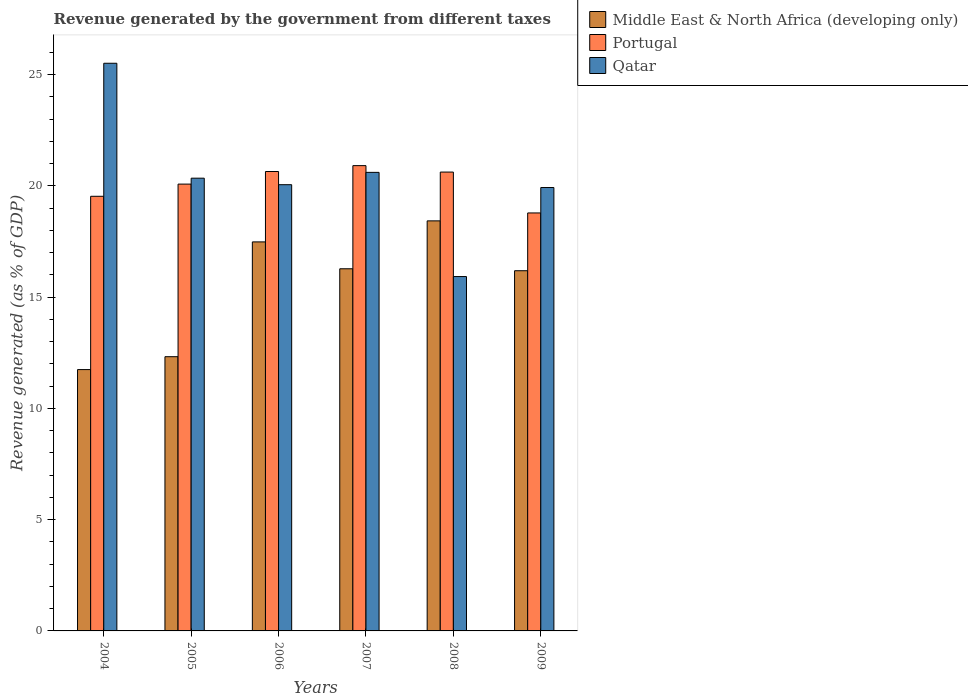How many different coloured bars are there?
Your response must be concise. 3. How many groups of bars are there?
Ensure brevity in your answer.  6. Are the number of bars per tick equal to the number of legend labels?
Give a very brief answer. Yes. Are the number of bars on each tick of the X-axis equal?
Provide a succinct answer. Yes. What is the revenue generated by the government in Qatar in 2008?
Ensure brevity in your answer.  15.92. Across all years, what is the maximum revenue generated by the government in Qatar?
Give a very brief answer. 25.51. Across all years, what is the minimum revenue generated by the government in Portugal?
Ensure brevity in your answer.  18.78. In which year was the revenue generated by the government in Middle East & North Africa (developing only) maximum?
Give a very brief answer. 2008. In which year was the revenue generated by the government in Qatar minimum?
Your response must be concise. 2008. What is the total revenue generated by the government in Qatar in the graph?
Your answer should be compact. 122.36. What is the difference between the revenue generated by the government in Portugal in 2008 and that in 2009?
Your answer should be very brief. 1.84. What is the difference between the revenue generated by the government in Portugal in 2008 and the revenue generated by the government in Middle East & North Africa (developing only) in 2004?
Offer a very short reply. 8.88. What is the average revenue generated by the government in Portugal per year?
Your answer should be very brief. 20.09. In the year 2006, what is the difference between the revenue generated by the government in Portugal and revenue generated by the government in Middle East & North Africa (developing only)?
Your response must be concise. 3.16. What is the ratio of the revenue generated by the government in Portugal in 2006 to that in 2009?
Make the answer very short. 1.1. Is the difference between the revenue generated by the government in Portugal in 2005 and 2008 greater than the difference between the revenue generated by the government in Middle East & North Africa (developing only) in 2005 and 2008?
Offer a terse response. Yes. What is the difference between the highest and the second highest revenue generated by the government in Portugal?
Keep it short and to the point. 0.26. What is the difference between the highest and the lowest revenue generated by the government in Qatar?
Your answer should be compact. 9.58. In how many years, is the revenue generated by the government in Qatar greater than the average revenue generated by the government in Qatar taken over all years?
Provide a short and direct response. 2. Is the sum of the revenue generated by the government in Qatar in 2005 and 2007 greater than the maximum revenue generated by the government in Portugal across all years?
Your answer should be very brief. Yes. What does the 1st bar from the right in 2009 represents?
Give a very brief answer. Qatar. How many bars are there?
Ensure brevity in your answer.  18. How many years are there in the graph?
Ensure brevity in your answer.  6. What is the difference between two consecutive major ticks on the Y-axis?
Provide a short and direct response. 5. Are the values on the major ticks of Y-axis written in scientific E-notation?
Provide a short and direct response. No. Does the graph contain any zero values?
Ensure brevity in your answer.  No. Where does the legend appear in the graph?
Provide a short and direct response. Top right. How are the legend labels stacked?
Give a very brief answer. Vertical. What is the title of the graph?
Your answer should be compact. Revenue generated by the government from different taxes. What is the label or title of the Y-axis?
Your answer should be compact. Revenue generated (as % of GDP). What is the Revenue generated (as % of GDP) in Middle East & North Africa (developing only) in 2004?
Your response must be concise. 11.74. What is the Revenue generated (as % of GDP) in Portugal in 2004?
Make the answer very short. 19.53. What is the Revenue generated (as % of GDP) of Qatar in 2004?
Your answer should be compact. 25.51. What is the Revenue generated (as % of GDP) of Middle East & North Africa (developing only) in 2005?
Give a very brief answer. 12.32. What is the Revenue generated (as % of GDP) in Portugal in 2005?
Offer a very short reply. 20.08. What is the Revenue generated (as % of GDP) of Qatar in 2005?
Your response must be concise. 20.34. What is the Revenue generated (as % of GDP) of Middle East & North Africa (developing only) in 2006?
Ensure brevity in your answer.  17.48. What is the Revenue generated (as % of GDP) in Portugal in 2006?
Give a very brief answer. 20.64. What is the Revenue generated (as % of GDP) in Qatar in 2006?
Ensure brevity in your answer.  20.05. What is the Revenue generated (as % of GDP) in Middle East & North Africa (developing only) in 2007?
Provide a short and direct response. 16.27. What is the Revenue generated (as % of GDP) in Portugal in 2007?
Make the answer very short. 20.91. What is the Revenue generated (as % of GDP) of Qatar in 2007?
Provide a short and direct response. 20.61. What is the Revenue generated (as % of GDP) of Middle East & North Africa (developing only) in 2008?
Your answer should be very brief. 18.43. What is the Revenue generated (as % of GDP) in Portugal in 2008?
Your answer should be very brief. 20.62. What is the Revenue generated (as % of GDP) of Qatar in 2008?
Make the answer very short. 15.92. What is the Revenue generated (as % of GDP) in Middle East & North Africa (developing only) in 2009?
Offer a terse response. 16.19. What is the Revenue generated (as % of GDP) of Portugal in 2009?
Offer a terse response. 18.78. What is the Revenue generated (as % of GDP) in Qatar in 2009?
Offer a very short reply. 19.92. Across all years, what is the maximum Revenue generated (as % of GDP) of Middle East & North Africa (developing only)?
Offer a very short reply. 18.43. Across all years, what is the maximum Revenue generated (as % of GDP) of Portugal?
Provide a short and direct response. 20.91. Across all years, what is the maximum Revenue generated (as % of GDP) in Qatar?
Your response must be concise. 25.51. Across all years, what is the minimum Revenue generated (as % of GDP) in Middle East & North Africa (developing only)?
Make the answer very short. 11.74. Across all years, what is the minimum Revenue generated (as % of GDP) in Portugal?
Offer a terse response. 18.78. Across all years, what is the minimum Revenue generated (as % of GDP) in Qatar?
Give a very brief answer. 15.92. What is the total Revenue generated (as % of GDP) of Middle East & North Africa (developing only) in the graph?
Keep it short and to the point. 92.43. What is the total Revenue generated (as % of GDP) in Portugal in the graph?
Keep it short and to the point. 120.56. What is the total Revenue generated (as % of GDP) in Qatar in the graph?
Your answer should be compact. 122.36. What is the difference between the Revenue generated (as % of GDP) in Middle East & North Africa (developing only) in 2004 and that in 2005?
Make the answer very short. -0.58. What is the difference between the Revenue generated (as % of GDP) of Portugal in 2004 and that in 2005?
Offer a very short reply. -0.55. What is the difference between the Revenue generated (as % of GDP) in Qatar in 2004 and that in 2005?
Give a very brief answer. 5.16. What is the difference between the Revenue generated (as % of GDP) in Middle East & North Africa (developing only) in 2004 and that in 2006?
Offer a very short reply. -5.74. What is the difference between the Revenue generated (as % of GDP) of Portugal in 2004 and that in 2006?
Ensure brevity in your answer.  -1.11. What is the difference between the Revenue generated (as % of GDP) in Qatar in 2004 and that in 2006?
Give a very brief answer. 5.46. What is the difference between the Revenue generated (as % of GDP) of Middle East & North Africa (developing only) in 2004 and that in 2007?
Your answer should be very brief. -4.53. What is the difference between the Revenue generated (as % of GDP) in Portugal in 2004 and that in 2007?
Give a very brief answer. -1.38. What is the difference between the Revenue generated (as % of GDP) of Qatar in 2004 and that in 2007?
Offer a terse response. 4.9. What is the difference between the Revenue generated (as % of GDP) of Middle East & North Africa (developing only) in 2004 and that in 2008?
Provide a short and direct response. -6.68. What is the difference between the Revenue generated (as % of GDP) of Portugal in 2004 and that in 2008?
Your answer should be very brief. -1.09. What is the difference between the Revenue generated (as % of GDP) of Qatar in 2004 and that in 2008?
Provide a succinct answer. 9.58. What is the difference between the Revenue generated (as % of GDP) of Middle East & North Africa (developing only) in 2004 and that in 2009?
Ensure brevity in your answer.  -4.44. What is the difference between the Revenue generated (as % of GDP) in Portugal in 2004 and that in 2009?
Provide a succinct answer. 0.75. What is the difference between the Revenue generated (as % of GDP) of Qatar in 2004 and that in 2009?
Give a very brief answer. 5.58. What is the difference between the Revenue generated (as % of GDP) in Middle East & North Africa (developing only) in 2005 and that in 2006?
Provide a short and direct response. -5.16. What is the difference between the Revenue generated (as % of GDP) in Portugal in 2005 and that in 2006?
Make the answer very short. -0.57. What is the difference between the Revenue generated (as % of GDP) in Qatar in 2005 and that in 2006?
Provide a short and direct response. 0.29. What is the difference between the Revenue generated (as % of GDP) in Middle East & North Africa (developing only) in 2005 and that in 2007?
Your response must be concise. -3.95. What is the difference between the Revenue generated (as % of GDP) of Portugal in 2005 and that in 2007?
Your answer should be compact. -0.83. What is the difference between the Revenue generated (as % of GDP) of Qatar in 2005 and that in 2007?
Your response must be concise. -0.26. What is the difference between the Revenue generated (as % of GDP) of Middle East & North Africa (developing only) in 2005 and that in 2008?
Keep it short and to the point. -6.1. What is the difference between the Revenue generated (as % of GDP) of Portugal in 2005 and that in 2008?
Offer a terse response. -0.54. What is the difference between the Revenue generated (as % of GDP) in Qatar in 2005 and that in 2008?
Provide a short and direct response. 4.42. What is the difference between the Revenue generated (as % of GDP) of Middle East & North Africa (developing only) in 2005 and that in 2009?
Give a very brief answer. -3.86. What is the difference between the Revenue generated (as % of GDP) of Portugal in 2005 and that in 2009?
Keep it short and to the point. 1.3. What is the difference between the Revenue generated (as % of GDP) in Qatar in 2005 and that in 2009?
Your response must be concise. 0.42. What is the difference between the Revenue generated (as % of GDP) in Middle East & North Africa (developing only) in 2006 and that in 2007?
Keep it short and to the point. 1.21. What is the difference between the Revenue generated (as % of GDP) in Portugal in 2006 and that in 2007?
Give a very brief answer. -0.26. What is the difference between the Revenue generated (as % of GDP) in Qatar in 2006 and that in 2007?
Provide a short and direct response. -0.55. What is the difference between the Revenue generated (as % of GDP) of Middle East & North Africa (developing only) in 2006 and that in 2008?
Keep it short and to the point. -0.95. What is the difference between the Revenue generated (as % of GDP) of Portugal in 2006 and that in 2008?
Your answer should be compact. 0.03. What is the difference between the Revenue generated (as % of GDP) in Qatar in 2006 and that in 2008?
Provide a succinct answer. 4.13. What is the difference between the Revenue generated (as % of GDP) in Middle East & North Africa (developing only) in 2006 and that in 2009?
Make the answer very short. 1.3. What is the difference between the Revenue generated (as % of GDP) in Portugal in 2006 and that in 2009?
Provide a short and direct response. 1.86. What is the difference between the Revenue generated (as % of GDP) in Qatar in 2006 and that in 2009?
Ensure brevity in your answer.  0.13. What is the difference between the Revenue generated (as % of GDP) of Middle East & North Africa (developing only) in 2007 and that in 2008?
Provide a succinct answer. -2.15. What is the difference between the Revenue generated (as % of GDP) in Portugal in 2007 and that in 2008?
Give a very brief answer. 0.29. What is the difference between the Revenue generated (as % of GDP) of Qatar in 2007 and that in 2008?
Provide a succinct answer. 4.68. What is the difference between the Revenue generated (as % of GDP) in Middle East & North Africa (developing only) in 2007 and that in 2009?
Keep it short and to the point. 0.09. What is the difference between the Revenue generated (as % of GDP) of Portugal in 2007 and that in 2009?
Provide a short and direct response. 2.13. What is the difference between the Revenue generated (as % of GDP) of Qatar in 2007 and that in 2009?
Offer a very short reply. 0.68. What is the difference between the Revenue generated (as % of GDP) in Middle East & North Africa (developing only) in 2008 and that in 2009?
Keep it short and to the point. 2.24. What is the difference between the Revenue generated (as % of GDP) in Portugal in 2008 and that in 2009?
Give a very brief answer. 1.84. What is the difference between the Revenue generated (as % of GDP) in Qatar in 2008 and that in 2009?
Provide a succinct answer. -4. What is the difference between the Revenue generated (as % of GDP) in Middle East & North Africa (developing only) in 2004 and the Revenue generated (as % of GDP) in Portugal in 2005?
Make the answer very short. -8.34. What is the difference between the Revenue generated (as % of GDP) of Middle East & North Africa (developing only) in 2004 and the Revenue generated (as % of GDP) of Qatar in 2005?
Make the answer very short. -8.6. What is the difference between the Revenue generated (as % of GDP) in Portugal in 2004 and the Revenue generated (as % of GDP) in Qatar in 2005?
Offer a very short reply. -0.81. What is the difference between the Revenue generated (as % of GDP) of Middle East & North Africa (developing only) in 2004 and the Revenue generated (as % of GDP) of Portugal in 2006?
Keep it short and to the point. -8.9. What is the difference between the Revenue generated (as % of GDP) of Middle East & North Africa (developing only) in 2004 and the Revenue generated (as % of GDP) of Qatar in 2006?
Your response must be concise. -8.31. What is the difference between the Revenue generated (as % of GDP) of Portugal in 2004 and the Revenue generated (as % of GDP) of Qatar in 2006?
Your response must be concise. -0.52. What is the difference between the Revenue generated (as % of GDP) in Middle East & North Africa (developing only) in 2004 and the Revenue generated (as % of GDP) in Portugal in 2007?
Give a very brief answer. -9.16. What is the difference between the Revenue generated (as % of GDP) in Middle East & North Africa (developing only) in 2004 and the Revenue generated (as % of GDP) in Qatar in 2007?
Keep it short and to the point. -8.86. What is the difference between the Revenue generated (as % of GDP) in Portugal in 2004 and the Revenue generated (as % of GDP) in Qatar in 2007?
Give a very brief answer. -1.07. What is the difference between the Revenue generated (as % of GDP) in Middle East & North Africa (developing only) in 2004 and the Revenue generated (as % of GDP) in Portugal in 2008?
Your answer should be very brief. -8.88. What is the difference between the Revenue generated (as % of GDP) in Middle East & North Africa (developing only) in 2004 and the Revenue generated (as % of GDP) in Qatar in 2008?
Keep it short and to the point. -4.18. What is the difference between the Revenue generated (as % of GDP) in Portugal in 2004 and the Revenue generated (as % of GDP) in Qatar in 2008?
Offer a very short reply. 3.61. What is the difference between the Revenue generated (as % of GDP) in Middle East & North Africa (developing only) in 2004 and the Revenue generated (as % of GDP) in Portugal in 2009?
Provide a short and direct response. -7.04. What is the difference between the Revenue generated (as % of GDP) of Middle East & North Africa (developing only) in 2004 and the Revenue generated (as % of GDP) of Qatar in 2009?
Keep it short and to the point. -8.18. What is the difference between the Revenue generated (as % of GDP) in Portugal in 2004 and the Revenue generated (as % of GDP) in Qatar in 2009?
Ensure brevity in your answer.  -0.39. What is the difference between the Revenue generated (as % of GDP) of Middle East & North Africa (developing only) in 2005 and the Revenue generated (as % of GDP) of Portugal in 2006?
Offer a very short reply. -8.32. What is the difference between the Revenue generated (as % of GDP) of Middle East & North Africa (developing only) in 2005 and the Revenue generated (as % of GDP) of Qatar in 2006?
Keep it short and to the point. -7.73. What is the difference between the Revenue generated (as % of GDP) in Portugal in 2005 and the Revenue generated (as % of GDP) in Qatar in 2006?
Ensure brevity in your answer.  0.03. What is the difference between the Revenue generated (as % of GDP) in Middle East & North Africa (developing only) in 2005 and the Revenue generated (as % of GDP) in Portugal in 2007?
Offer a terse response. -8.58. What is the difference between the Revenue generated (as % of GDP) of Middle East & North Africa (developing only) in 2005 and the Revenue generated (as % of GDP) of Qatar in 2007?
Your answer should be compact. -8.28. What is the difference between the Revenue generated (as % of GDP) of Portugal in 2005 and the Revenue generated (as % of GDP) of Qatar in 2007?
Provide a succinct answer. -0.53. What is the difference between the Revenue generated (as % of GDP) in Middle East & North Africa (developing only) in 2005 and the Revenue generated (as % of GDP) in Portugal in 2008?
Give a very brief answer. -8.3. What is the difference between the Revenue generated (as % of GDP) of Middle East & North Africa (developing only) in 2005 and the Revenue generated (as % of GDP) of Qatar in 2008?
Your answer should be compact. -3.6. What is the difference between the Revenue generated (as % of GDP) in Portugal in 2005 and the Revenue generated (as % of GDP) in Qatar in 2008?
Your answer should be compact. 4.15. What is the difference between the Revenue generated (as % of GDP) of Middle East & North Africa (developing only) in 2005 and the Revenue generated (as % of GDP) of Portugal in 2009?
Offer a terse response. -6.46. What is the difference between the Revenue generated (as % of GDP) of Middle East & North Africa (developing only) in 2005 and the Revenue generated (as % of GDP) of Qatar in 2009?
Provide a succinct answer. -7.6. What is the difference between the Revenue generated (as % of GDP) in Portugal in 2005 and the Revenue generated (as % of GDP) in Qatar in 2009?
Your answer should be very brief. 0.15. What is the difference between the Revenue generated (as % of GDP) of Middle East & North Africa (developing only) in 2006 and the Revenue generated (as % of GDP) of Portugal in 2007?
Ensure brevity in your answer.  -3.43. What is the difference between the Revenue generated (as % of GDP) in Middle East & North Africa (developing only) in 2006 and the Revenue generated (as % of GDP) in Qatar in 2007?
Your answer should be very brief. -3.12. What is the difference between the Revenue generated (as % of GDP) of Portugal in 2006 and the Revenue generated (as % of GDP) of Qatar in 2007?
Offer a terse response. 0.04. What is the difference between the Revenue generated (as % of GDP) in Middle East & North Africa (developing only) in 2006 and the Revenue generated (as % of GDP) in Portugal in 2008?
Your response must be concise. -3.14. What is the difference between the Revenue generated (as % of GDP) in Middle East & North Africa (developing only) in 2006 and the Revenue generated (as % of GDP) in Qatar in 2008?
Your answer should be very brief. 1.56. What is the difference between the Revenue generated (as % of GDP) of Portugal in 2006 and the Revenue generated (as % of GDP) of Qatar in 2008?
Your response must be concise. 4.72. What is the difference between the Revenue generated (as % of GDP) of Middle East & North Africa (developing only) in 2006 and the Revenue generated (as % of GDP) of Portugal in 2009?
Your answer should be very brief. -1.3. What is the difference between the Revenue generated (as % of GDP) of Middle East & North Africa (developing only) in 2006 and the Revenue generated (as % of GDP) of Qatar in 2009?
Keep it short and to the point. -2.44. What is the difference between the Revenue generated (as % of GDP) of Portugal in 2006 and the Revenue generated (as % of GDP) of Qatar in 2009?
Ensure brevity in your answer.  0.72. What is the difference between the Revenue generated (as % of GDP) in Middle East & North Africa (developing only) in 2007 and the Revenue generated (as % of GDP) in Portugal in 2008?
Give a very brief answer. -4.34. What is the difference between the Revenue generated (as % of GDP) in Middle East & North Africa (developing only) in 2007 and the Revenue generated (as % of GDP) in Qatar in 2008?
Ensure brevity in your answer.  0.35. What is the difference between the Revenue generated (as % of GDP) in Portugal in 2007 and the Revenue generated (as % of GDP) in Qatar in 2008?
Your answer should be very brief. 4.98. What is the difference between the Revenue generated (as % of GDP) of Middle East & North Africa (developing only) in 2007 and the Revenue generated (as % of GDP) of Portugal in 2009?
Give a very brief answer. -2.51. What is the difference between the Revenue generated (as % of GDP) in Middle East & North Africa (developing only) in 2007 and the Revenue generated (as % of GDP) in Qatar in 2009?
Make the answer very short. -3.65. What is the difference between the Revenue generated (as % of GDP) in Portugal in 2007 and the Revenue generated (as % of GDP) in Qatar in 2009?
Make the answer very short. 0.98. What is the difference between the Revenue generated (as % of GDP) of Middle East & North Africa (developing only) in 2008 and the Revenue generated (as % of GDP) of Portugal in 2009?
Make the answer very short. -0.36. What is the difference between the Revenue generated (as % of GDP) of Middle East & North Africa (developing only) in 2008 and the Revenue generated (as % of GDP) of Qatar in 2009?
Offer a terse response. -1.5. What is the difference between the Revenue generated (as % of GDP) of Portugal in 2008 and the Revenue generated (as % of GDP) of Qatar in 2009?
Provide a short and direct response. 0.69. What is the average Revenue generated (as % of GDP) in Middle East & North Africa (developing only) per year?
Your answer should be very brief. 15.41. What is the average Revenue generated (as % of GDP) in Portugal per year?
Ensure brevity in your answer.  20.09. What is the average Revenue generated (as % of GDP) of Qatar per year?
Provide a short and direct response. 20.39. In the year 2004, what is the difference between the Revenue generated (as % of GDP) of Middle East & North Africa (developing only) and Revenue generated (as % of GDP) of Portugal?
Your answer should be compact. -7.79. In the year 2004, what is the difference between the Revenue generated (as % of GDP) in Middle East & North Africa (developing only) and Revenue generated (as % of GDP) in Qatar?
Provide a short and direct response. -13.77. In the year 2004, what is the difference between the Revenue generated (as % of GDP) of Portugal and Revenue generated (as % of GDP) of Qatar?
Give a very brief answer. -5.98. In the year 2005, what is the difference between the Revenue generated (as % of GDP) of Middle East & North Africa (developing only) and Revenue generated (as % of GDP) of Portugal?
Provide a succinct answer. -7.76. In the year 2005, what is the difference between the Revenue generated (as % of GDP) of Middle East & North Africa (developing only) and Revenue generated (as % of GDP) of Qatar?
Your response must be concise. -8.02. In the year 2005, what is the difference between the Revenue generated (as % of GDP) of Portugal and Revenue generated (as % of GDP) of Qatar?
Your answer should be compact. -0.27. In the year 2006, what is the difference between the Revenue generated (as % of GDP) in Middle East & North Africa (developing only) and Revenue generated (as % of GDP) in Portugal?
Your answer should be compact. -3.16. In the year 2006, what is the difference between the Revenue generated (as % of GDP) in Middle East & North Africa (developing only) and Revenue generated (as % of GDP) in Qatar?
Give a very brief answer. -2.57. In the year 2006, what is the difference between the Revenue generated (as % of GDP) in Portugal and Revenue generated (as % of GDP) in Qatar?
Provide a succinct answer. 0.59. In the year 2007, what is the difference between the Revenue generated (as % of GDP) of Middle East & North Africa (developing only) and Revenue generated (as % of GDP) of Portugal?
Offer a very short reply. -4.63. In the year 2007, what is the difference between the Revenue generated (as % of GDP) in Middle East & North Africa (developing only) and Revenue generated (as % of GDP) in Qatar?
Make the answer very short. -4.33. In the year 2007, what is the difference between the Revenue generated (as % of GDP) in Portugal and Revenue generated (as % of GDP) in Qatar?
Offer a very short reply. 0.3. In the year 2008, what is the difference between the Revenue generated (as % of GDP) of Middle East & North Africa (developing only) and Revenue generated (as % of GDP) of Portugal?
Keep it short and to the point. -2.19. In the year 2008, what is the difference between the Revenue generated (as % of GDP) of Middle East & North Africa (developing only) and Revenue generated (as % of GDP) of Qatar?
Provide a succinct answer. 2.5. In the year 2008, what is the difference between the Revenue generated (as % of GDP) of Portugal and Revenue generated (as % of GDP) of Qatar?
Ensure brevity in your answer.  4.7. In the year 2009, what is the difference between the Revenue generated (as % of GDP) in Middle East & North Africa (developing only) and Revenue generated (as % of GDP) in Portugal?
Your response must be concise. -2.6. In the year 2009, what is the difference between the Revenue generated (as % of GDP) in Middle East & North Africa (developing only) and Revenue generated (as % of GDP) in Qatar?
Offer a very short reply. -3.74. In the year 2009, what is the difference between the Revenue generated (as % of GDP) of Portugal and Revenue generated (as % of GDP) of Qatar?
Your response must be concise. -1.14. What is the ratio of the Revenue generated (as % of GDP) of Middle East & North Africa (developing only) in 2004 to that in 2005?
Your answer should be very brief. 0.95. What is the ratio of the Revenue generated (as % of GDP) in Portugal in 2004 to that in 2005?
Ensure brevity in your answer.  0.97. What is the ratio of the Revenue generated (as % of GDP) in Qatar in 2004 to that in 2005?
Ensure brevity in your answer.  1.25. What is the ratio of the Revenue generated (as % of GDP) of Middle East & North Africa (developing only) in 2004 to that in 2006?
Make the answer very short. 0.67. What is the ratio of the Revenue generated (as % of GDP) of Portugal in 2004 to that in 2006?
Make the answer very short. 0.95. What is the ratio of the Revenue generated (as % of GDP) of Qatar in 2004 to that in 2006?
Keep it short and to the point. 1.27. What is the ratio of the Revenue generated (as % of GDP) of Middle East & North Africa (developing only) in 2004 to that in 2007?
Offer a terse response. 0.72. What is the ratio of the Revenue generated (as % of GDP) of Portugal in 2004 to that in 2007?
Provide a short and direct response. 0.93. What is the ratio of the Revenue generated (as % of GDP) of Qatar in 2004 to that in 2007?
Give a very brief answer. 1.24. What is the ratio of the Revenue generated (as % of GDP) of Middle East & North Africa (developing only) in 2004 to that in 2008?
Ensure brevity in your answer.  0.64. What is the ratio of the Revenue generated (as % of GDP) of Portugal in 2004 to that in 2008?
Your response must be concise. 0.95. What is the ratio of the Revenue generated (as % of GDP) in Qatar in 2004 to that in 2008?
Make the answer very short. 1.6. What is the ratio of the Revenue generated (as % of GDP) in Middle East & North Africa (developing only) in 2004 to that in 2009?
Ensure brevity in your answer.  0.73. What is the ratio of the Revenue generated (as % of GDP) of Portugal in 2004 to that in 2009?
Give a very brief answer. 1.04. What is the ratio of the Revenue generated (as % of GDP) of Qatar in 2004 to that in 2009?
Provide a succinct answer. 1.28. What is the ratio of the Revenue generated (as % of GDP) of Middle East & North Africa (developing only) in 2005 to that in 2006?
Offer a very short reply. 0.7. What is the ratio of the Revenue generated (as % of GDP) of Portugal in 2005 to that in 2006?
Offer a terse response. 0.97. What is the ratio of the Revenue generated (as % of GDP) of Qatar in 2005 to that in 2006?
Your answer should be compact. 1.01. What is the ratio of the Revenue generated (as % of GDP) of Middle East & North Africa (developing only) in 2005 to that in 2007?
Offer a very short reply. 0.76. What is the ratio of the Revenue generated (as % of GDP) in Portugal in 2005 to that in 2007?
Offer a very short reply. 0.96. What is the ratio of the Revenue generated (as % of GDP) of Qatar in 2005 to that in 2007?
Your response must be concise. 0.99. What is the ratio of the Revenue generated (as % of GDP) of Middle East & North Africa (developing only) in 2005 to that in 2008?
Your response must be concise. 0.67. What is the ratio of the Revenue generated (as % of GDP) of Portugal in 2005 to that in 2008?
Offer a very short reply. 0.97. What is the ratio of the Revenue generated (as % of GDP) in Qatar in 2005 to that in 2008?
Your response must be concise. 1.28. What is the ratio of the Revenue generated (as % of GDP) in Middle East & North Africa (developing only) in 2005 to that in 2009?
Offer a very short reply. 0.76. What is the ratio of the Revenue generated (as % of GDP) of Portugal in 2005 to that in 2009?
Offer a terse response. 1.07. What is the ratio of the Revenue generated (as % of GDP) of Qatar in 2005 to that in 2009?
Your answer should be very brief. 1.02. What is the ratio of the Revenue generated (as % of GDP) in Middle East & North Africa (developing only) in 2006 to that in 2007?
Provide a succinct answer. 1.07. What is the ratio of the Revenue generated (as % of GDP) of Portugal in 2006 to that in 2007?
Ensure brevity in your answer.  0.99. What is the ratio of the Revenue generated (as % of GDP) of Qatar in 2006 to that in 2007?
Your answer should be very brief. 0.97. What is the ratio of the Revenue generated (as % of GDP) in Middle East & North Africa (developing only) in 2006 to that in 2008?
Your answer should be very brief. 0.95. What is the ratio of the Revenue generated (as % of GDP) of Portugal in 2006 to that in 2008?
Give a very brief answer. 1. What is the ratio of the Revenue generated (as % of GDP) in Qatar in 2006 to that in 2008?
Ensure brevity in your answer.  1.26. What is the ratio of the Revenue generated (as % of GDP) of Portugal in 2006 to that in 2009?
Make the answer very short. 1.1. What is the ratio of the Revenue generated (as % of GDP) of Qatar in 2006 to that in 2009?
Make the answer very short. 1.01. What is the ratio of the Revenue generated (as % of GDP) of Middle East & North Africa (developing only) in 2007 to that in 2008?
Offer a terse response. 0.88. What is the ratio of the Revenue generated (as % of GDP) of Qatar in 2007 to that in 2008?
Offer a very short reply. 1.29. What is the ratio of the Revenue generated (as % of GDP) in Middle East & North Africa (developing only) in 2007 to that in 2009?
Make the answer very short. 1.01. What is the ratio of the Revenue generated (as % of GDP) of Portugal in 2007 to that in 2009?
Make the answer very short. 1.11. What is the ratio of the Revenue generated (as % of GDP) of Qatar in 2007 to that in 2009?
Give a very brief answer. 1.03. What is the ratio of the Revenue generated (as % of GDP) of Middle East & North Africa (developing only) in 2008 to that in 2009?
Offer a terse response. 1.14. What is the ratio of the Revenue generated (as % of GDP) of Portugal in 2008 to that in 2009?
Offer a terse response. 1.1. What is the ratio of the Revenue generated (as % of GDP) of Qatar in 2008 to that in 2009?
Provide a short and direct response. 0.8. What is the difference between the highest and the second highest Revenue generated (as % of GDP) of Middle East & North Africa (developing only)?
Your answer should be compact. 0.95. What is the difference between the highest and the second highest Revenue generated (as % of GDP) of Portugal?
Make the answer very short. 0.26. What is the difference between the highest and the second highest Revenue generated (as % of GDP) of Qatar?
Your answer should be very brief. 4.9. What is the difference between the highest and the lowest Revenue generated (as % of GDP) of Middle East & North Africa (developing only)?
Make the answer very short. 6.68. What is the difference between the highest and the lowest Revenue generated (as % of GDP) of Portugal?
Your response must be concise. 2.13. What is the difference between the highest and the lowest Revenue generated (as % of GDP) of Qatar?
Provide a succinct answer. 9.58. 